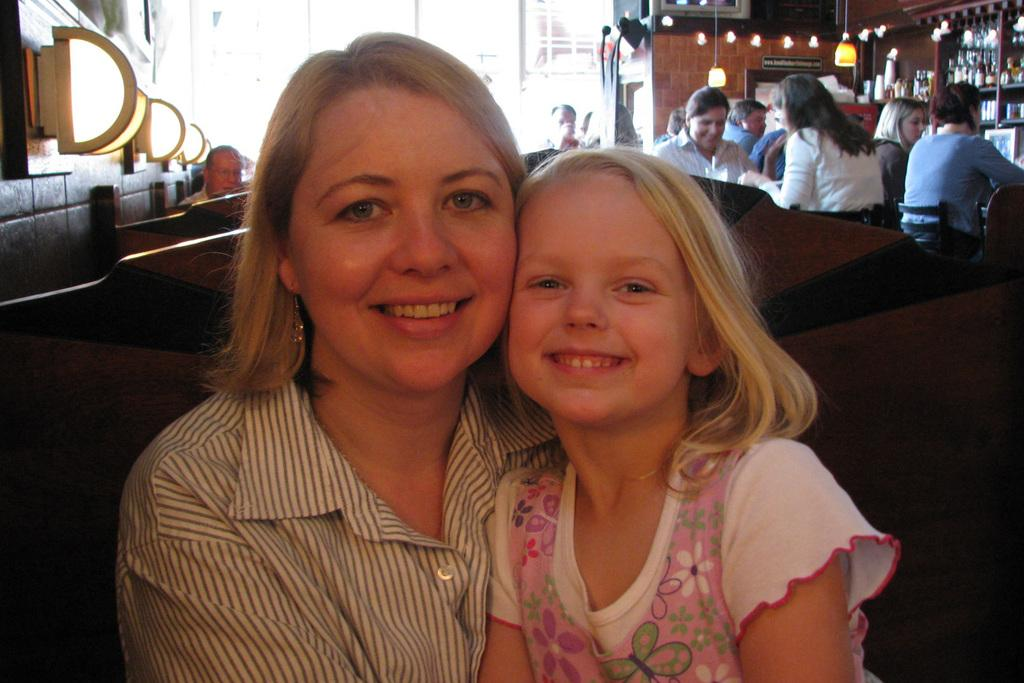What are the people in the image doing? The people in the image are sitting. What can be seen on the wall in the image? There are objects on the wall in the image. What type of illumination is present in the image? There are lights visible in the image. What type of storage is present in the image? There are shelves with objects in the image. What type of toothpaste is being used by the people in the image? There is no toothpaste present in the image; it is not mentioned or depicted. 